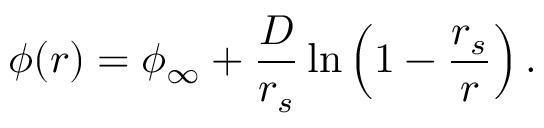<formula> <loc_0><loc_0><loc_500><loc_500>\phi ( r ) = \phi _ { \infty } + { \frac { D } { r _ { s } } } \ln \left ( 1 - { \frac { r _ { s } } { r } } \right ) .</formula> 